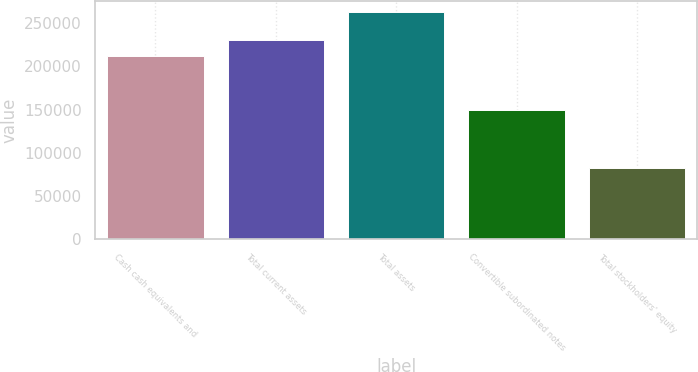<chart> <loc_0><loc_0><loc_500><loc_500><bar_chart><fcel>Cash cash equivalents and<fcel>Total current assets<fcel>Total assets<fcel>Convertible subordinated notes<fcel>Total stockholders' equity<nl><fcel>212456<fcel>230538<fcel>262711<fcel>150000<fcel>81890<nl></chart> 